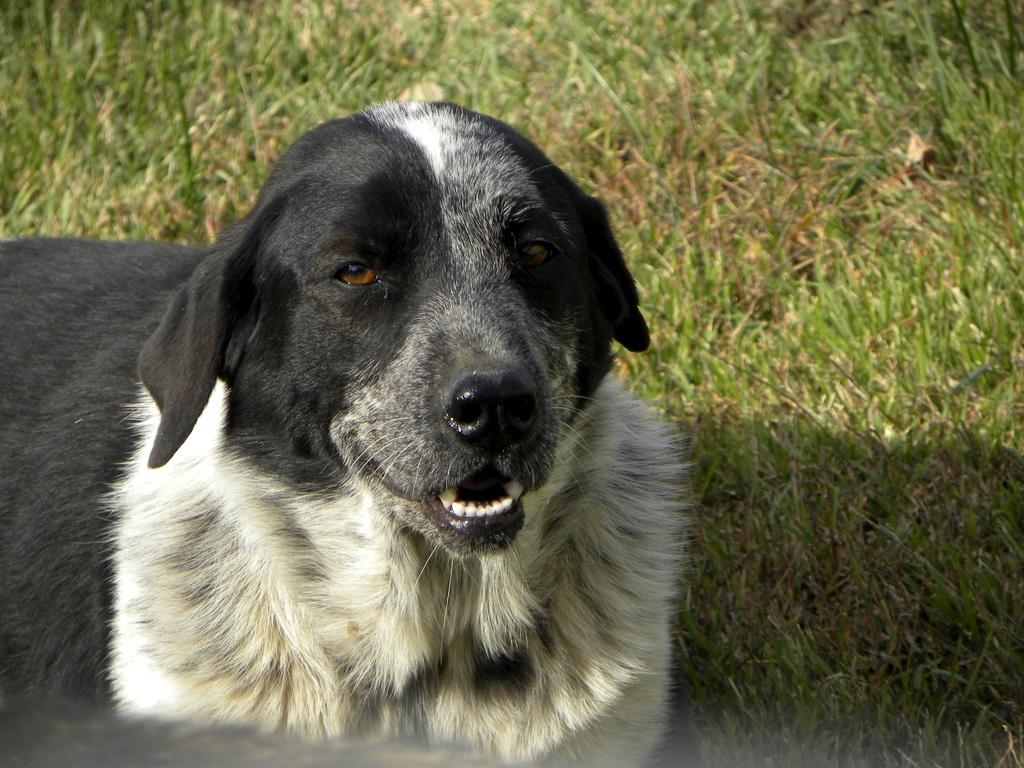What is the main subject of the image? There is a dog in the center of the image. Can you describe the appearance of the dog? The dog is black and white in color. What type of environment is visible in the background of the image? There is grass visible in the background of the image. What type of polish is the dog applying to its nails in the image? There is no polish or nail-related activity present in the image; the dog is simply standing on the grass. 